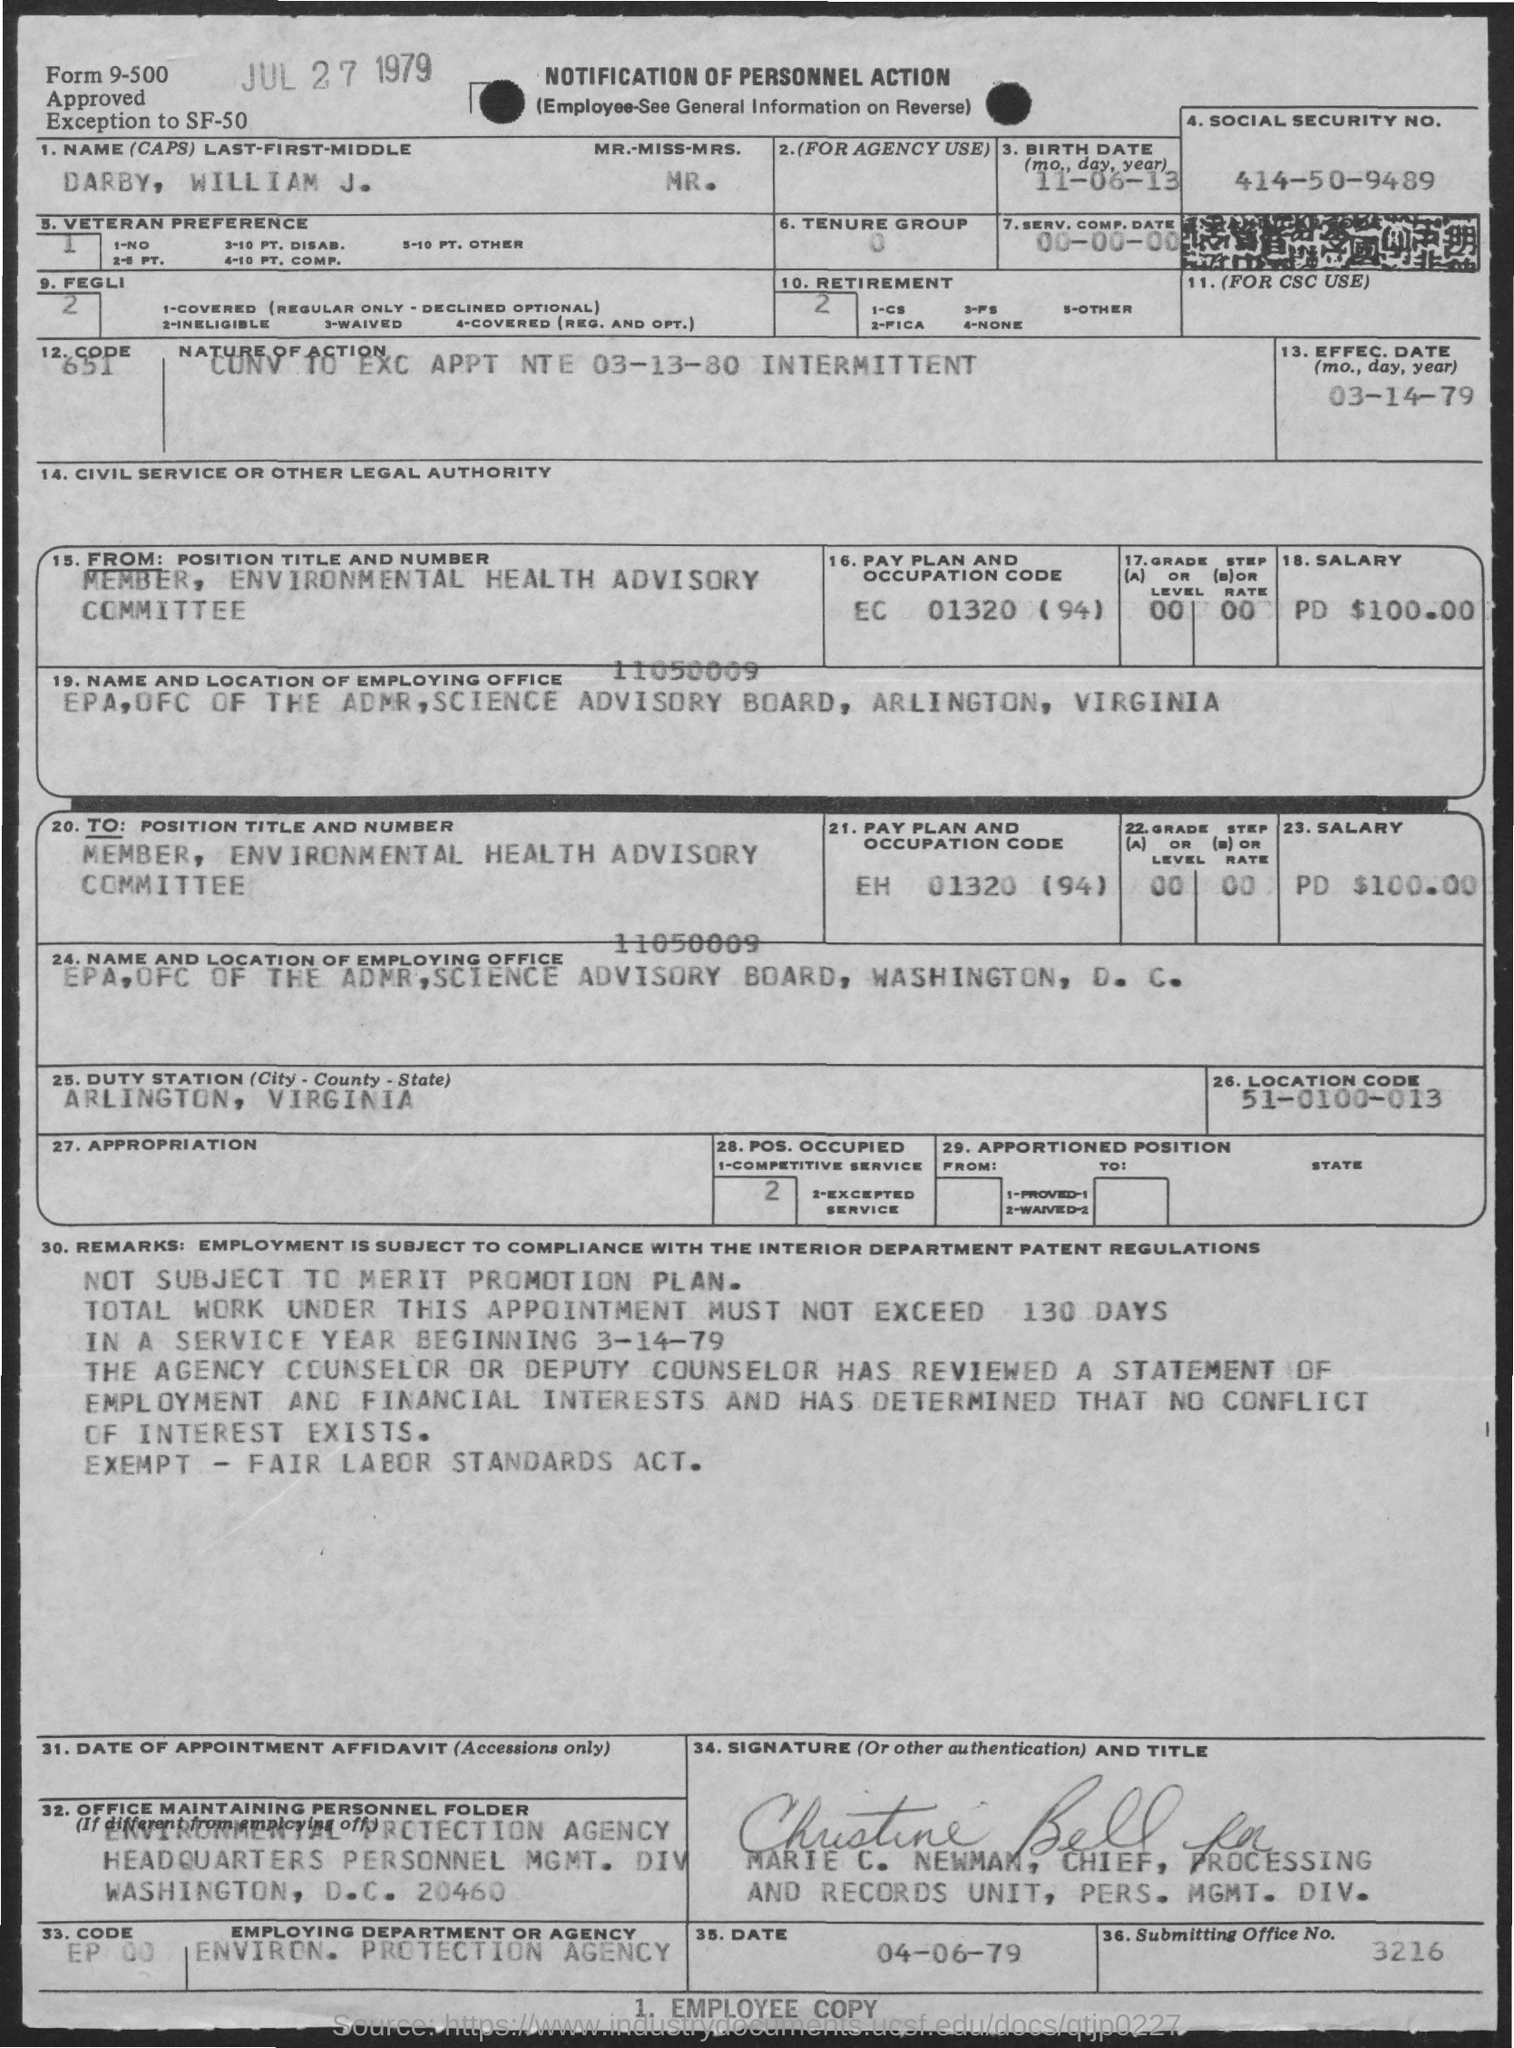Give some essential details in this illustration. The nature of action is to convert to excitation appointments, which will begin on an intermittent basis starting on or before March 13, 1980. The duty station is Arlington. The submitting office number is 3216. A notification is being made about a personnel action, and this is the notification itself. The effective date of the action is March 14, 1979. 